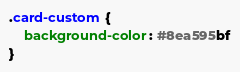Convert code to text. <code><loc_0><loc_0><loc_500><loc_500><_CSS_>.card-custom {
    background-color: #8ea595bf
}</code> 